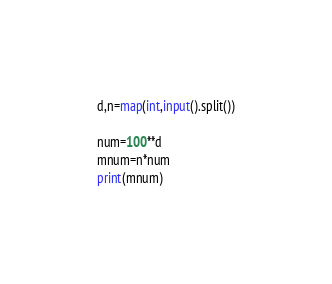<code> <loc_0><loc_0><loc_500><loc_500><_Python_>d,n=map(int,input().split())

num=100**d
mnum=n*num
print(mnum)
</code> 